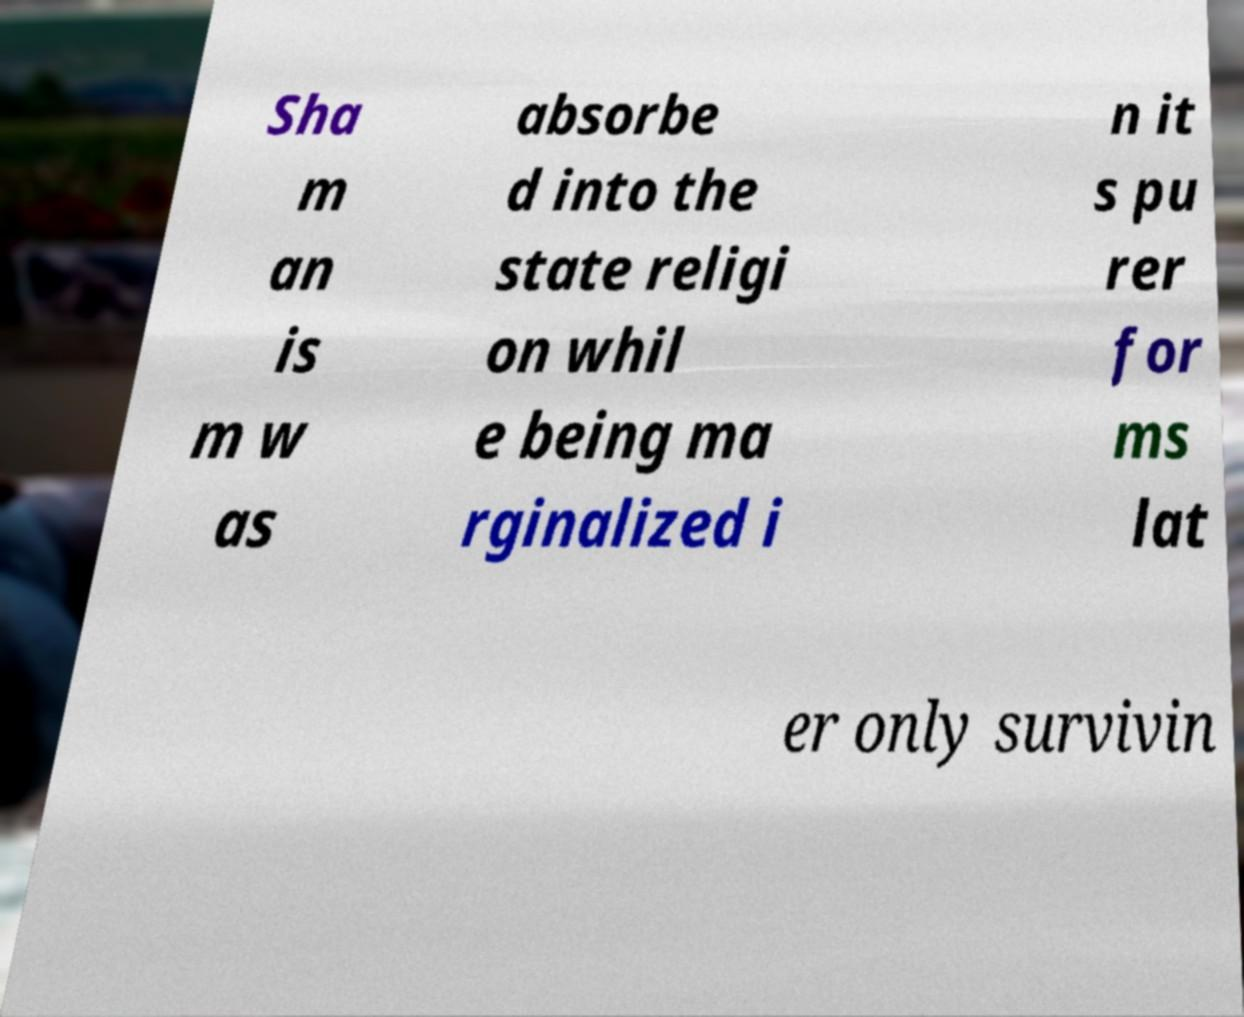Could you extract and type out the text from this image? Sha m an is m w as absorbe d into the state religi on whil e being ma rginalized i n it s pu rer for ms lat er only survivin 